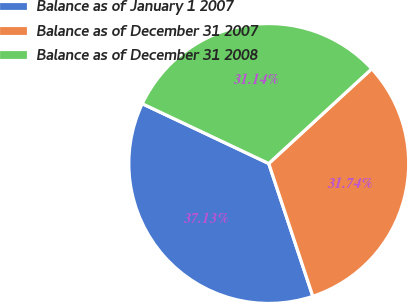Convert chart. <chart><loc_0><loc_0><loc_500><loc_500><pie_chart><fcel>Balance as of January 1 2007<fcel>Balance as of December 31 2007<fcel>Balance as of December 31 2008<nl><fcel>37.13%<fcel>31.74%<fcel>31.14%<nl></chart> 